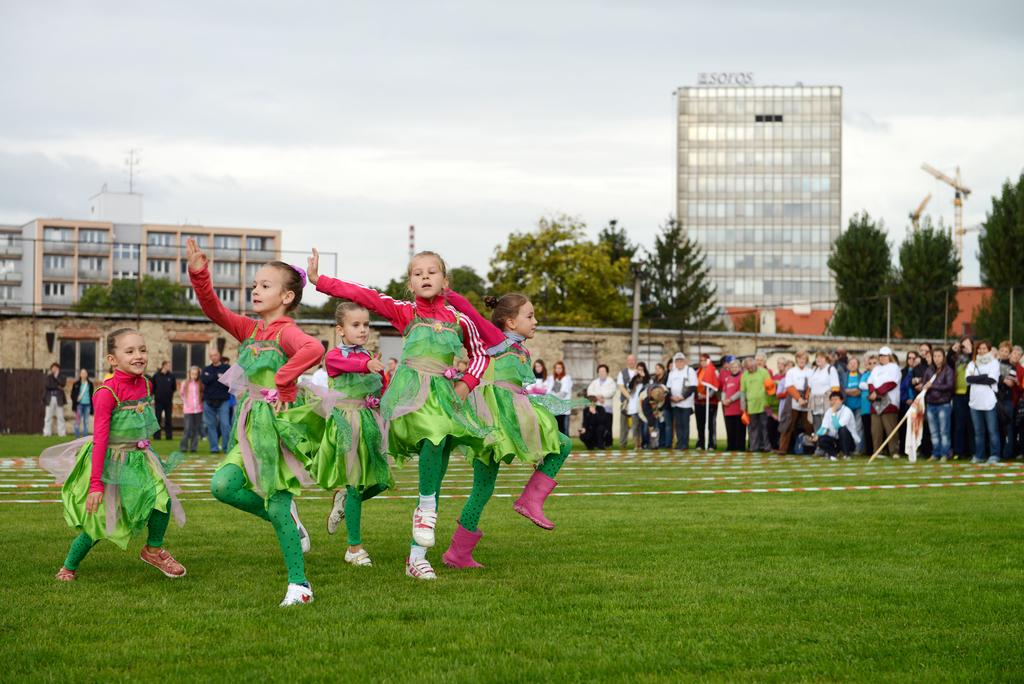What are the girls in the image doing? The girls in the image are dancing. What can be seen in the background of the image? There are many people, trees, buildings, and poles visible in the background of the image. How does the drain affect the girls' dancing in the image? There is no drain present in the image, so it does not affect the girls' dancing. 